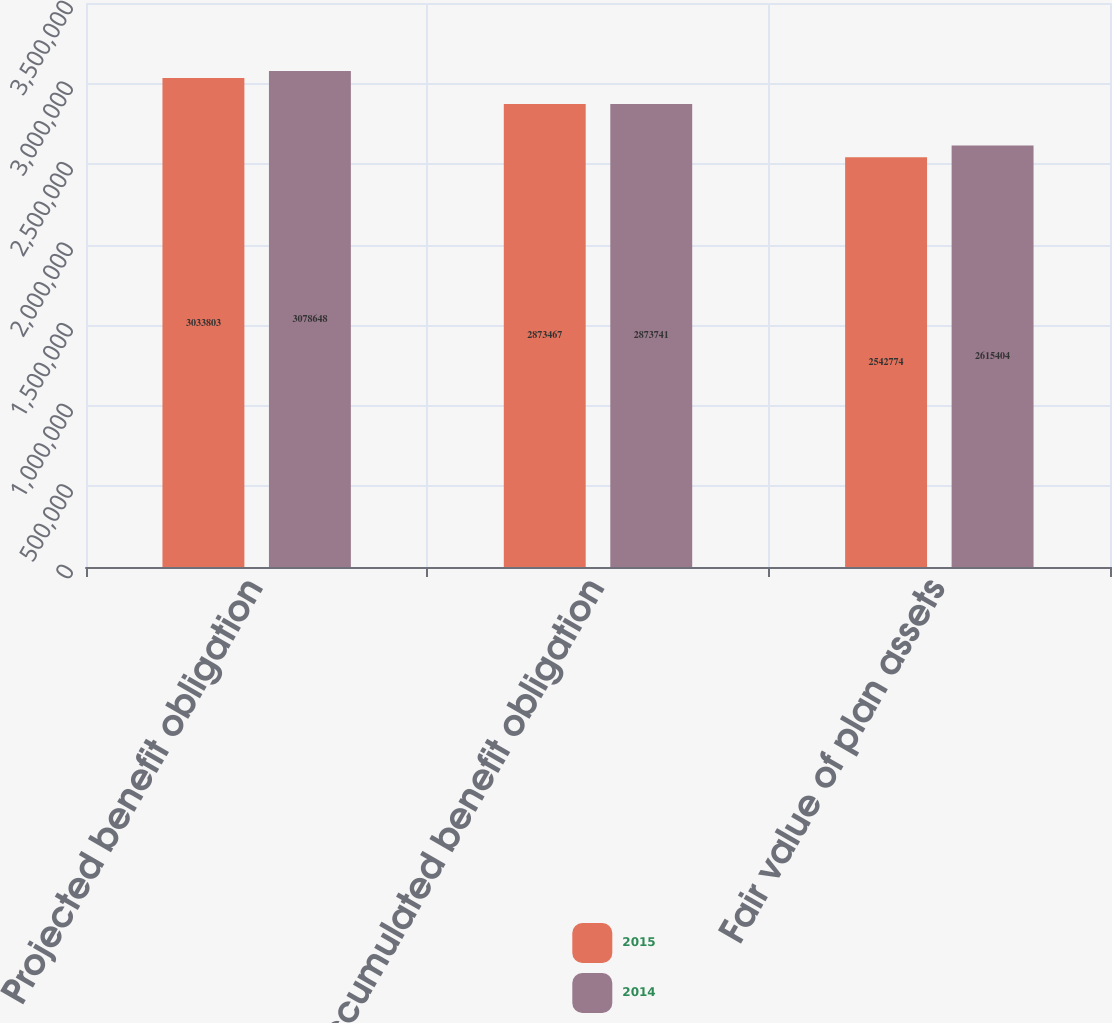<chart> <loc_0><loc_0><loc_500><loc_500><stacked_bar_chart><ecel><fcel>Projected benefit obligation<fcel>Accumulated benefit obligation<fcel>Fair value of plan assets<nl><fcel>2015<fcel>3.0338e+06<fcel>2.87347e+06<fcel>2.54277e+06<nl><fcel>2014<fcel>3.07865e+06<fcel>2.87374e+06<fcel>2.6154e+06<nl></chart> 